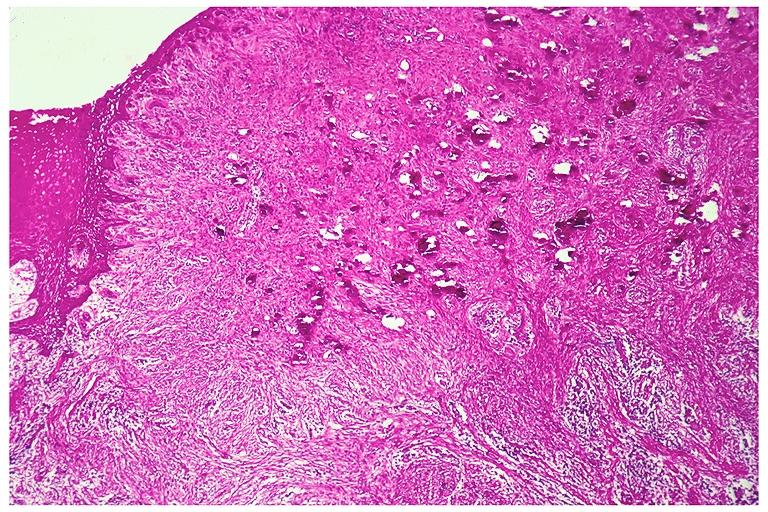does the superior vena cava show peripheral cemento-ossifying fibroma?
Answer the question using a single word or phrase. No 